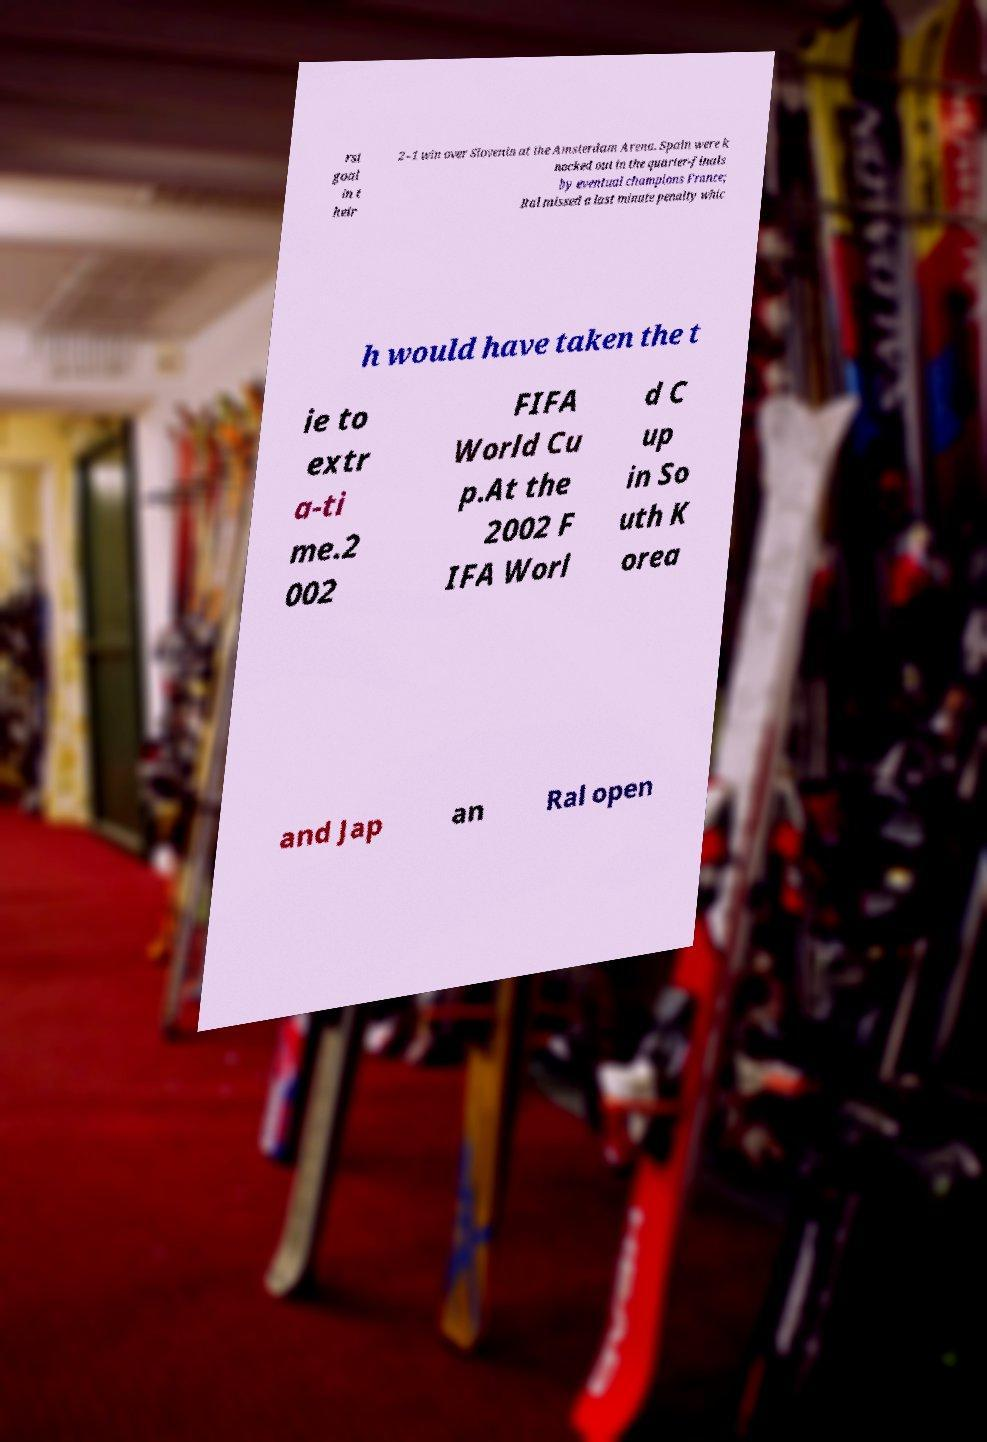Can you accurately transcribe the text from the provided image for me? rst goal in t heir 2–1 win over Slovenia at the Amsterdam Arena. Spain were k nocked out in the quarter-finals by eventual champions France; Ral missed a last minute penalty whic h would have taken the t ie to extr a-ti me.2 002 FIFA World Cu p.At the 2002 F IFA Worl d C up in So uth K orea and Jap an Ral open 